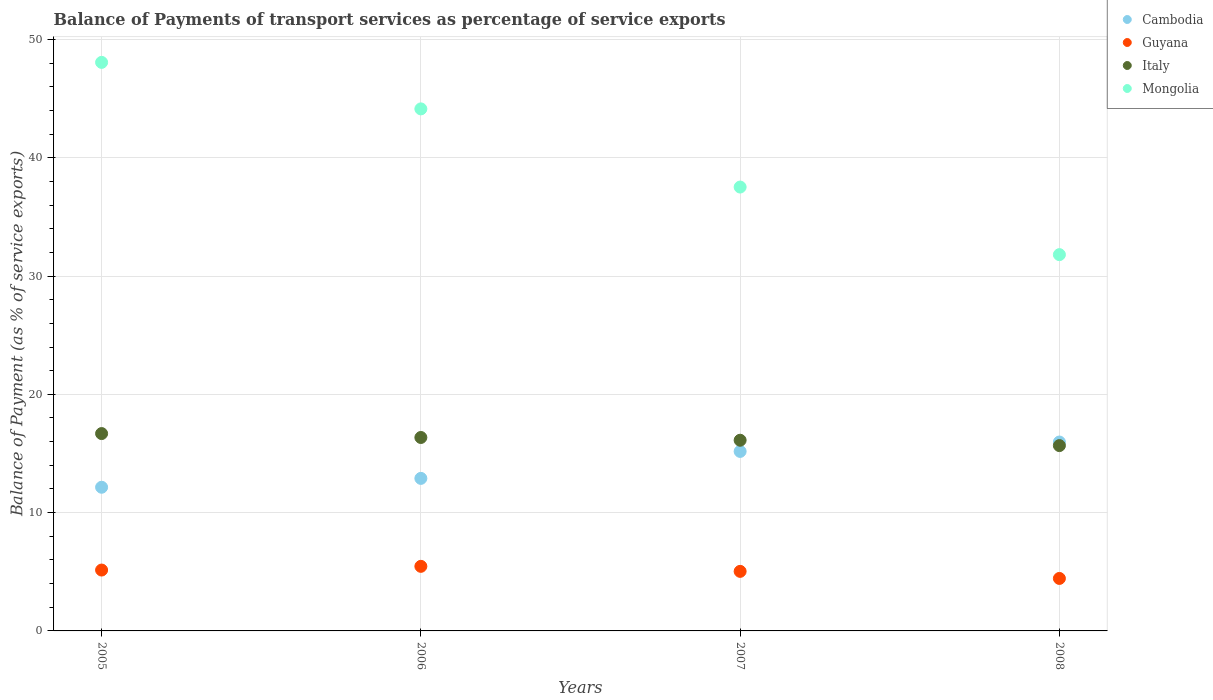Is the number of dotlines equal to the number of legend labels?
Offer a terse response. Yes. What is the balance of payments of transport services in Italy in 2008?
Give a very brief answer. 15.67. Across all years, what is the maximum balance of payments of transport services in Italy?
Ensure brevity in your answer.  16.68. Across all years, what is the minimum balance of payments of transport services in Cambodia?
Your answer should be compact. 12.14. In which year was the balance of payments of transport services in Mongolia maximum?
Provide a short and direct response. 2005. In which year was the balance of payments of transport services in Guyana minimum?
Ensure brevity in your answer.  2008. What is the total balance of payments of transport services in Cambodia in the graph?
Your response must be concise. 56.18. What is the difference between the balance of payments of transport services in Italy in 2005 and that in 2006?
Give a very brief answer. 0.33. What is the difference between the balance of payments of transport services in Guyana in 2007 and the balance of payments of transport services in Italy in 2008?
Offer a terse response. -10.63. What is the average balance of payments of transport services in Guyana per year?
Your response must be concise. 5.02. In the year 2008, what is the difference between the balance of payments of transport services in Cambodia and balance of payments of transport services in Mongolia?
Your answer should be very brief. -15.84. In how many years, is the balance of payments of transport services in Cambodia greater than 28 %?
Offer a very short reply. 0. What is the ratio of the balance of payments of transport services in Cambodia in 2005 to that in 2008?
Make the answer very short. 0.76. Is the balance of payments of transport services in Mongolia in 2005 less than that in 2008?
Offer a terse response. No. What is the difference between the highest and the second highest balance of payments of transport services in Mongolia?
Ensure brevity in your answer.  3.93. What is the difference between the highest and the lowest balance of payments of transport services in Guyana?
Ensure brevity in your answer.  1.02. In how many years, is the balance of payments of transport services in Italy greater than the average balance of payments of transport services in Italy taken over all years?
Keep it short and to the point. 2. Is it the case that in every year, the sum of the balance of payments of transport services in Cambodia and balance of payments of transport services in Guyana  is greater than the sum of balance of payments of transport services in Mongolia and balance of payments of transport services in Italy?
Ensure brevity in your answer.  No. Does the balance of payments of transport services in Guyana monotonically increase over the years?
Ensure brevity in your answer.  No. Is the balance of payments of transport services in Mongolia strictly greater than the balance of payments of transport services in Italy over the years?
Your answer should be very brief. Yes. Is the balance of payments of transport services in Mongolia strictly less than the balance of payments of transport services in Guyana over the years?
Provide a short and direct response. No. How many years are there in the graph?
Ensure brevity in your answer.  4. What is the difference between two consecutive major ticks on the Y-axis?
Your response must be concise. 10. Are the values on the major ticks of Y-axis written in scientific E-notation?
Keep it short and to the point. No. Does the graph contain any zero values?
Ensure brevity in your answer.  No. How many legend labels are there?
Provide a short and direct response. 4. How are the legend labels stacked?
Give a very brief answer. Vertical. What is the title of the graph?
Give a very brief answer. Balance of Payments of transport services as percentage of service exports. What is the label or title of the Y-axis?
Your answer should be very brief. Balance of Payment (as % of service exports). What is the Balance of Payment (as % of service exports) in Cambodia in 2005?
Offer a terse response. 12.14. What is the Balance of Payment (as % of service exports) of Guyana in 2005?
Your answer should be very brief. 5.15. What is the Balance of Payment (as % of service exports) of Italy in 2005?
Your answer should be compact. 16.68. What is the Balance of Payment (as % of service exports) in Mongolia in 2005?
Offer a very short reply. 48.06. What is the Balance of Payment (as % of service exports) in Cambodia in 2006?
Keep it short and to the point. 12.89. What is the Balance of Payment (as % of service exports) of Guyana in 2006?
Provide a succinct answer. 5.46. What is the Balance of Payment (as % of service exports) in Italy in 2006?
Give a very brief answer. 16.35. What is the Balance of Payment (as % of service exports) in Mongolia in 2006?
Your answer should be compact. 44.13. What is the Balance of Payment (as % of service exports) in Cambodia in 2007?
Provide a short and direct response. 15.17. What is the Balance of Payment (as % of service exports) of Guyana in 2007?
Your answer should be compact. 5.03. What is the Balance of Payment (as % of service exports) in Italy in 2007?
Make the answer very short. 16.12. What is the Balance of Payment (as % of service exports) in Mongolia in 2007?
Provide a short and direct response. 37.52. What is the Balance of Payment (as % of service exports) of Cambodia in 2008?
Your response must be concise. 15.97. What is the Balance of Payment (as % of service exports) in Guyana in 2008?
Offer a very short reply. 4.44. What is the Balance of Payment (as % of service exports) of Italy in 2008?
Offer a very short reply. 15.67. What is the Balance of Payment (as % of service exports) in Mongolia in 2008?
Offer a very short reply. 31.81. Across all years, what is the maximum Balance of Payment (as % of service exports) of Cambodia?
Keep it short and to the point. 15.97. Across all years, what is the maximum Balance of Payment (as % of service exports) of Guyana?
Keep it short and to the point. 5.46. Across all years, what is the maximum Balance of Payment (as % of service exports) of Italy?
Offer a very short reply. 16.68. Across all years, what is the maximum Balance of Payment (as % of service exports) of Mongolia?
Provide a short and direct response. 48.06. Across all years, what is the minimum Balance of Payment (as % of service exports) of Cambodia?
Offer a very short reply. 12.14. Across all years, what is the minimum Balance of Payment (as % of service exports) of Guyana?
Your answer should be very brief. 4.44. Across all years, what is the minimum Balance of Payment (as % of service exports) in Italy?
Provide a succinct answer. 15.67. Across all years, what is the minimum Balance of Payment (as % of service exports) in Mongolia?
Provide a short and direct response. 31.81. What is the total Balance of Payment (as % of service exports) of Cambodia in the graph?
Your answer should be very brief. 56.18. What is the total Balance of Payment (as % of service exports) in Guyana in the graph?
Your response must be concise. 20.08. What is the total Balance of Payment (as % of service exports) in Italy in the graph?
Give a very brief answer. 64.82. What is the total Balance of Payment (as % of service exports) in Mongolia in the graph?
Give a very brief answer. 161.52. What is the difference between the Balance of Payment (as % of service exports) in Cambodia in 2005 and that in 2006?
Keep it short and to the point. -0.75. What is the difference between the Balance of Payment (as % of service exports) of Guyana in 2005 and that in 2006?
Give a very brief answer. -0.31. What is the difference between the Balance of Payment (as % of service exports) of Italy in 2005 and that in 2006?
Ensure brevity in your answer.  0.33. What is the difference between the Balance of Payment (as % of service exports) of Mongolia in 2005 and that in 2006?
Offer a terse response. 3.93. What is the difference between the Balance of Payment (as % of service exports) in Cambodia in 2005 and that in 2007?
Provide a succinct answer. -3.03. What is the difference between the Balance of Payment (as % of service exports) of Guyana in 2005 and that in 2007?
Make the answer very short. 0.11. What is the difference between the Balance of Payment (as % of service exports) of Italy in 2005 and that in 2007?
Offer a very short reply. 0.56. What is the difference between the Balance of Payment (as % of service exports) in Mongolia in 2005 and that in 2007?
Make the answer very short. 10.54. What is the difference between the Balance of Payment (as % of service exports) of Cambodia in 2005 and that in 2008?
Your answer should be very brief. -3.82. What is the difference between the Balance of Payment (as % of service exports) of Guyana in 2005 and that in 2008?
Your response must be concise. 0.71. What is the difference between the Balance of Payment (as % of service exports) in Italy in 2005 and that in 2008?
Offer a very short reply. 1.02. What is the difference between the Balance of Payment (as % of service exports) of Mongolia in 2005 and that in 2008?
Your response must be concise. 16.25. What is the difference between the Balance of Payment (as % of service exports) in Cambodia in 2006 and that in 2007?
Ensure brevity in your answer.  -2.28. What is the difference between the Balance of Payment (as % of service exports) in Guyana in 2006 and that in 2007?
Offer a very short reply. 0.42. What is the difference between the Balance of Payment (as % of service exports) in Italy in 2006 and that in 2007?
Make the answer very short. 0.23. What is the difference between the Balance of Payment (as % of service exports) of Mongolia in 2006 and that in 2007?
Offer a terse response. 6.61. What is the difference between the Balance of Payment (as % of service exports) of Cambodia in 2006 and that in 2008?
Your answer should be very brief. -3.07. What is the difference between the Balance of Payment (as % of service exports) of Guyana in 2006 and that in 2008?
Your response must be concise. 1.02. What is the difference between the Balance of Payment (as % of service exports) in Italy in 2006 and that in 2008?
Offer a terse response. 0.69. What is the difference between the Balance of Payment (as % of service exports) in Mongolia in 2006 and that in 2008?
Your response must be concise. 12.32. What is the difference between the Balance of Payment (as % of service exports) of Cambodia in 2007 and that in 2008?
Give a very brief answer. -0.79. What is the difference between the Balance of Payment (as % of service exports) in Guyana in 2007 and that in 2008?
Keep it short and to the point. 0.6. What is the difference between the Balance of Payment (as % of service exports) of Italy in 2007 and that in 2008?
Ensure brevity in your answer.  0.45. What is the difference between the Balance of Payment (as % of service exports) in Mongolia in 2007 and that in 2008?
Provide a short and direct response. 5.71. What is the difference between the Balance of Payment (as % of service exports) of Cambodia in 2005 and the Balance of Payment (as % of service exports) of Guyana in 2006?
Your answer should be very brief. 6.69. What is the difference between the Balance of Payment (as % of service exports) of Cambodia in 2005 and the Balance of Payment (as % of service exports) of Italy in 2006?
Your answer should be very brief. -4.21. What is the difference between the Balance of Payment (as % of service exports) in Cambodia in 2005 and the Balance of Payment (as % of service exports) in Mongolia in 2006?
Keep it short and to the point. -31.98. What is the difference between the Balance of Payment (as % of service exports) in Guyana in 2005 and the Balance of Payment (as % of service exports) in Italy in 2006?
Offer a terse response. -11.21. What is the difference between the Balance of Payment (as % of service exports) in Guyana in 2005 and the Balance of Payment (as % of service exports) in Mongolia in 2006?
Your response must be concise. -38.98. What is the difference between the Balance of Payment (as % of service exports) of Italy in 2005 and the Balance of Payment (as % of service exports) of Mongolia in 2006?
Keep it short and to the point. -27.45. What is the difference between the Balance of Payment (as % of service exports) in Cambodia in 2005 and the Balance of Payment (as % of service exports) in Guyana in 2007?
Provide a succinct answer. 7.11. What is the difference between the Balance of Payment (as % of service exports) in Cambodia in 2005 and the Balance of Payment (as % of service exports) in Italy in 2007?
Provide a short and direct response. -3.97. What is the difference between the Balance of Payment (as % of service exports) in Cambodia in 2005 and the Balance of Payment (as % of service exports) in Mongolia in 2007?
Your response must be concise. -25.38. What is the difference between the Balance of Payment (as % of service exports) of Guyana in 2005 and the Balance of Payment (as % of service exports) of Italy in 2007?
Ensure brevity in your answer.  -10.97. What is the difference between the Balance of Payment (as % of service exports) of Guyana in 2005 and the Balance of Payment (as % of service exports) of Mongolia in 2007?
Ensure brevity in your answer.  -32.38. What is the difference between the Balance of Payment (as % of service exports) in Italy in 2005 and the Balance of Payment (as % of service exports) in Mongolia in 2007?
Give a very brief answer. -20.84. What is the difference between the Balance of Payment (as % of service exports) of Cambodia in 2005 and the Balance of Payment (as % of service exports) of Guyana in 2008?
Keep it short and to the point. 7.71. What is the difference between the Balance of Payment (as % of service exports) of Cambodia in 2005 and the Balance of Payment (as % of service exports) of Italy in 2008?
Keep it short and to the point. -3.52. What is the difference between the Balance of Payment (as % of service exports) of Cambodia in 2005 and the Balance of Payment (as % of service exports) of Mongolia in 2008?
Your answer should be very brief. -19.66. What is the difference between the Balance of Payment (as % of service exports) of Guyana in 2005 and the Balance of Payment (as % of service exports) of Italy in 2008?
Keep it short and to the point. -10.52. What is the difference between the Balance of Payment (as % of service exports) in Guyana in 2005 and the Balance of Payment (as % of service exports) in Mongolia in 2008?
Offer a terse response. -26.66. What is the difference between the Balance of Payment (as % of service exports) of Italy in 2005 and the Balance of Payment (as % of service exports) of Mongolia in 2008?
Provide a succinct answer. -15.13. What is the difference between the Balance of Payment (as % of service exports) in Cambodia in 2006 and the Balance of Payment (as % of service exports) in Guyana in 2007?
Offer a terse response. 7.86. What is the difference between the Balance of Payment (as % of service exports) of Cambodia in 2006 and the Balance of Payment (as % of service exports) of Italy in 2007?
Ensure brevity in your answer.  -3.22. What is the difference between the Balance of Payment (as % of service exports) in Cambodia in 2006 and the Balance of Payment (as % of service exports) in Mongolia in 2007?
Offer a very short reply. -24.63. What is the difference between the Balance of Payment (as % of service exports) in Guyana in 2006 and the Balance of Payment (as % of service exports) in Italy in 2007?
Your answer should be very brief. -10.66. What is the difference between the Balance of Payment (as % of service exports) in Guyana in 2006 and the Balance of Payment (as % of service exports) in Mongolia in 2007?
Provide a succinct answer. -32.06. What is the difference between the Balance of Payment (as % of service exports) in Italy in 2006 and the Balance of Payment (as % of service exports) in Mongolia in 2007?
Provide a succinct answer. -21.17. What is the difference between the Balance of Payment (as % of service exports) in Cambodia in 2006 and the Balance of Payment (as % of service exports) in Guyana in 2008?
Offer a terse response. 8.46. What is the difference between the Balance of Payment (as % of service exports) in Cambodia in 2006 and the Balance of Payment (as % of service exports) in Italy in 2008?
Keep it short and to the point. -2.77. What is the difference between the Balance of Payment (as % of service exports) of Cambodia in 2006 and the Balance of Payment (as % of service exports) of Mongolia in 2008?
Provide a short and direct response. -18.91. What is the difference between the Balance of Payment (as % of service exports) in Guyana in 2006 and the Balance of Payment (as % of service exports) in Italy in 2008?
Offer a terse response. -10.21. What is the difference between the Balance of Payment (as % of service exports) in Guyana in 2006 and the Balance of Payment (as % of service exports) in Mongolia in 2008?
Your answer should be very brief. -26.35. What is the difference between the Balance of Payment (as % of service exports) in Italy in 2006 and the Balance of Payment (as % of service exports) in Mongolia in 2008?
Your answer should be very brief. -15.46. What is the difference between the Balance of Payment (as % of service exports) in Cambodia in 2007 and the Balance of Payment (as % of service exports) in Guyana in 2008?
Your response must be concise. 10.74. What is the difference between the Balance of Payment (as % of service exports) in Cambodia in 2007 and the Balance of Payment (as % of service exports) in Italy in 2008?
Provide a short and direct response. -0.49. What is the difference between the Balance of Payment (as % of service exports) in Cambodia in 2007 and the Balance of Payment (as % of service exports) in Mongolia in 2008?
Your answer should be compact. -16.63. What is the difference between the Balance of Payment (as % of service exports) in Guyana in 2007 and the Balance of Payment (as % of service exports) in Italy in 2008?
Give a very brief answer. -10.63. What is the difference between the Balance of Payment (as % of service exports) in Guyana in 2007 and the Balance of Payment (as % of service exports) in Mongolia in 2008?
Provide a short and direct response. -26.77. What is the difference between the Balance of Payment (as % of service exports) in Italy in 2007 and the Balance of Payment (as % of service exports) in Mongolia in 2008?
Make the answer very short. -15.69. What is the average Balance of Payment (as % of service exports) of Cambodia per year?
Offer a terse response. 14.05. What is the average Balance of Payment (as % of service exports) in Guyana per year?
Provide a short and direct response. 5.02. What is the average Balance of Payment (as % of service exports) in Italy per year?
Your response must be concise. 16.2. What is the average Balance of Payment (as % of service exports) of Mongolia per year?
Make the answer very short. 40.38. In the year 2005, what is the difference between the Balance of Payment (as % of service exports) in Cambodia and Balance of Payment (as % of service exports) in Guyana?
Make the answer very short. 7. In the year 2005, what is the difference between the Balance of Payment (as % of service exports) of Cambodia and Balance of Payment (as % of service exports) of Italy?
Give a very brief answer. -4.54. In the year 2005, what is the difference between the Balance of Payment (as % of service exports) of Cambodia and Balance of Payment (as % of service exports) of Mongolia?
Ensure brevity in your answer.  -35.92. In the year 2005, what is the difference between the Balance of Payment (as % of service exports) of Guyana and Balance of Payment (as % of service exports) of Italy?
Your response must be concise. -11.54. In the year 2005, what is the difference between the Balance of Payment (as % of service exports) in Guyana and Balance of Payment (as % of service exports) in Mongolia?
Your answer should be compact. -42.92. In the year 2005, what is the difference between the Balance of Payment (as % of service exports) in Italy and Balance of Payment (as % of service exports) in Mongolia?
Ensure brevity in your answer.  -31.38. In the year 2006, what is the difference between the Balance of Payment (as % of service exports) of Cambodia and Balance of Payment (as % of service exports) of Guyana?
Your response must be concise. 7.44. In the year 2006, what is the difference between the Balance of Payment (as % of service exports) in Cambodia and Balance of Payment (as % of service exports) in Italy?
Offer a terse response. -3.46. In the year 2006, what is the difference between the Balance of Payment (as % of service exports) of Cambodia and Balance of Payment (as % of service exports) of Mongolia?
Your answer should be compact. -31.23. In the year 2006, what is the difference between the Balance of Payment (as % of service exports) of Guyana and Balance of Payment (as % of service exports) of Italy?
Provide a short and direct response. -10.89. In the year 2006, what is the difference between the Balance of Payment (as % of service exports) in Guyana and Balance of Payment (as % of service exports) in Mongolia?
Ensure brevity in your answer.  -38.67. In the year 2006, what is the difference between the Balance of Payment (as % of service exports) in Italy and Balance of Payment (as % of service exports) in Mongolia?
Provide a succinct answer. -27.78. In the year 2007, what is the difference between the Balance of Payment (as % of service exports) of Cambodia and Balance of Payment (as % of service exports) of Guyana?
Offer a very short reply. 10.14. In the year 2007, what is the difference between the Balance of Payment (as % of service exports) of Cambodia and Balance of Payment (as % of service exports) of Italy?
Offer a terse response. -0.94. In the year 2007, what is the difference between the Balance of Payment (as % of service exports) of Cambodia and Balance of Payment (as % of service exports) of Mongolia?
Provide a short and direct response. -22.35. In the year 2007, what is the difference between the Balance of Payment (as % of service exports) in Guyana and Balance of Payment (as % of service exports) in Italy?
Make the answer very short. -11.08. In the year 2007, what is the difference between the Balance of Payment (as % of service exports) of Guyana and Balance of Payment (as % of service exports) of Mongolia?
Your answer should be compact. -32.49. In the year 2007, what is the difference between the Balance of Payment (as % of service exports) in Italy and Balance of Payment (as % of service exports) in Mongolia?
Provide a succinct answer. -21.4. In the year 2008, what is the difference between the Balance of Payment (as % of service exports) of Cambodia and Balance of Payment (as % of service exports) of Guyana?
Provide a succinct answer. 11.53. In the year 2008, what is the difference between the Balance of Payment (as % of service exports) in Cambodia and Balance of Payment (as % of service exports) in Italy?
Keep it short and to the point. 0.3. In the year 2008, what is the difference between the Balance of Payment (as % of service exports) of Cambodia and Balance of Payment (as % of service exports) of Mongolia?
Offer a terse response. -15.84. In the year 2008, what is the difference between the Balance of Payment (as % of service exports) of Guyana and Balance of Payment (as % of service exports) of Italy?
Your answer should be compact. -11.23. In the year 2008, what is the difference between the Balance of Payment (as % of service exports) of Guyana and Balance of Payment (as % of service exports) of Mongolia?
Offer a very short reply. -27.37. In the year 2008, what is the difference between the Balance of Payment (as % of service exports) of Italy and Balance of Payment (as % of service exports) of Mongolia?
Your response must be concise. -16.14. What is the ratio of the Balance of Payment (as % of service exports) in Cambodia in 2005 to that in 2006?
Your answer should be compact. 0.94. What is the ratio of the Balance of Payment (as % of service exports) in Guyana in 2005 to that in 2006?
Your answer should be very brief. 0.94. What is the ratio of the Balance of Payment (as % of service exports) in Italy in 2005 to that in 2006?
Your response must be concise. 1.02. What is the ratio of the Balance of Payment (as % of service exports) in Mongolia in 2005 to that in 2006?
Offer a very short reply. 1.09. What is the ratio of the Balance of Payment (as % of service exports) of Cambodia in 2005 to that in 2007?
Your answer should be very brief. 0.8. What is the ratio of the Balance of Payment (as % of service exports) of Guyana in 2005 to that in 2007?
Offer a terse response. 1.02. What is the ratio of the Balance of Payment (as % of service exports) of Italy in 2005 to that in 2007?
Keep it short and to the point. 1.03. What is the ratio of the Balance of Payment (as % of service exports) of Mongolia in 2005 to that in 2007?
Provide a short and direct response. 1.28. What is the ratio of the Balance of Payment (as % of service exports) of Cambodia in 2005 to that in 2008?
Your answer should be very brief. 0.76. What is the ratio of the Balance of Payment (as % of service exports) of Guyana in 2005 to that in 2008?
Provide a succinct answer. 1.16. What is the ratio of the Balance of Payment (as % of service exports) of Italy in 2005 to that in 2008?
Ensure brevity in your answer.  1.06. What is the ratio of the Balance of Payment (as % of service exports) in Mongolia in 2005 to that in 2008?
Offer a terse response. 1.51. What is the ratio of the Balance of Payment (as % of service exports) of Cambodia in 2006 to that in 2007?
Your response must be concise. 0.85. What is the ratio of the Balance of Payment (as % of service exports) in Guyana in 2006 to that in 2007?
Your response must be concise. 1.08. What is the ratio of the Balance of Payment (as % of service exports) in Italy in 2006 to that in 2007?
Ensure brevity in your answer.  1.01. What is the ratio of the Balance of Payment (as % of service exports) of Mongolia in 2006 to that in 2007?
Your answer should be very brief. 1.18. What is the ratio of the Balance of Payment (as % of service exports) in Cambodia in 2006 to that in 2008?
Your response must be concise. 0.81. What is the ratio of the Balance of Payment (as % of service exports) in Guyana in 2006 to that in 2008?
Give a very brief answer. 1.23. What is the ratio of the Balance of Payment (as % of service exports) in Italy in 2006 to that in 2008?
Offer a terse response. 1.04. What is the ratio of the Balance of Payment (as % of service exports) of Mongolia in 2006 to that in 2008?
Give a very brief answer. 1.39. What is the ratio of the Balance of Payment (as % of service exports) in Cambodia in 2007 to that in 2008?
Offer a very short reply. 0.95. What is the ratio of the Balance of Payment (as % of service exports) of Guyana in 2007 to that in 2008?
Ensure brevity in your answer.  1.13. What is the ratio of the Balance of Payment (as % of service exports) in Italy in 2007 to that in 2008?
Ensure brevity in your answer.  1.03. What is the ratio of the Balance of Payment (as % of service exports) of Mongolia in 2007 to that in 2008?
Make the answer very short. 1.18. What is the difference between the highest and the second highest Balance of Payment (as % of service exports) of Cambodia?
Provide a succinct answer. 0.79. What is the difference between the highest and the second highest Balance of Payment (as % of service exports) in Guyana?
Your answer should be compact. 0.31. What is the difference between the highest and the second highest Balance of Payment (as % of service exports) in Italy?
Provide a succinct answer. 0.33. What is the difference between the highest and the second highest Balance of Payment (as % of service exports) in Mongolia?
Your answer should be very brief. 3.93. What is the difference between the highest and the lowest Balance of Payment (as % of service exports) of Cambodia?
Provide a short and direct response. 3.82. What is the difference between the highest and the lowest Balance of Payment (as % of service exports) of Guyana?
Keep it short and to the point. 1.02. What is the difference between the highest and the lowest Balance of Payment (as % of service exports) of Italy?
Your answer should be very brief. 1.02. What is the difference between the highest and the lowest Balance of Payment (as % of service exports) in Mongolia?
Provide a short and direct response. 16.25. 